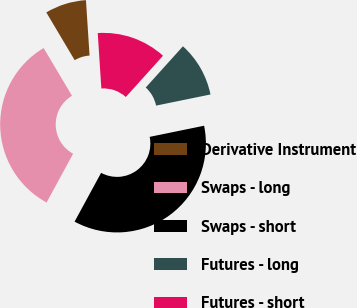Convert chart to OTSL. <chart><loc_0><loc_0><loc_500><loc_500><pie_chart><fcel>Derivative Instrument<fcel>Swaps - long<fcel>Swaps - short<fcel>Futures - long<fcel>Futures - short<nl><fcel>7.5%<fcel>33.54%<fcel>36.14%<fcel>10.11%<fcel>12.71%<nl></chart> 